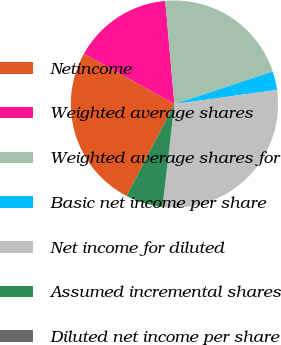Convert chart. <chart><loc_0><loc_0><loc_500><loc_500><pie_chart><fcel>Netincome<fcel>Weighted average shares<fcel>Weighted average shares for<fcel>Basic net income per share<fcel>Net income for diluted<fcel>Assumed incremental shares<fcel>Diluted net income per share<nl><fcel>25.43%<fcel>15.51%<fcel>21.32%<fcel>2.9%<fcel>29.03%<fcel>5.81%<fcel>0.0%<nl></chart> 